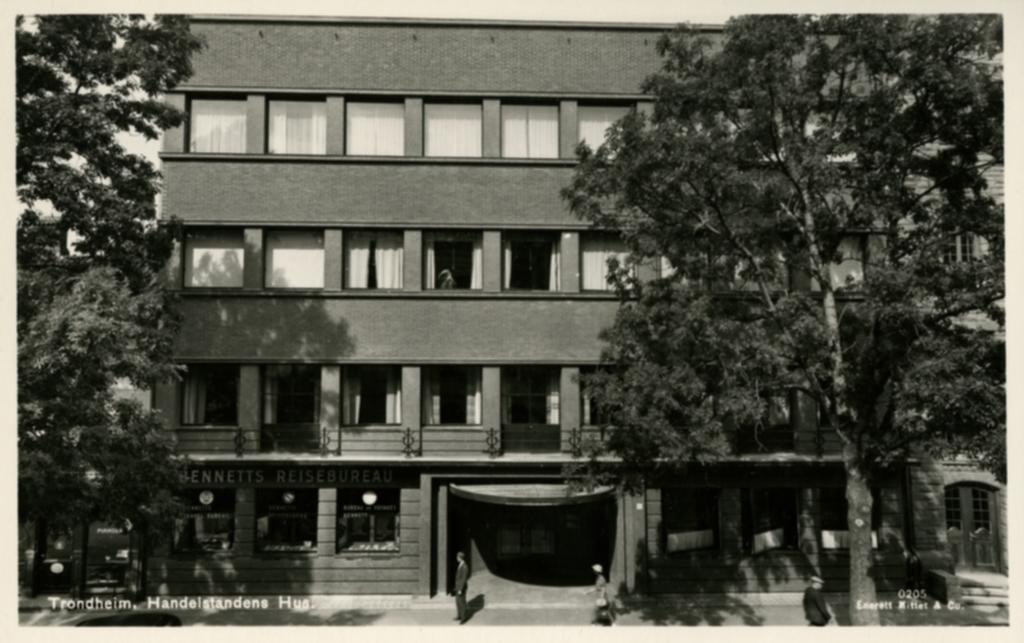In one or two sentences, can you explain what this image depicts? This is a black and white photo. In this picture we can see a building, windows, roof, board, doors. In the background of the image we can see the trees. At the bottom of the image we can see the road, some persons and text. 